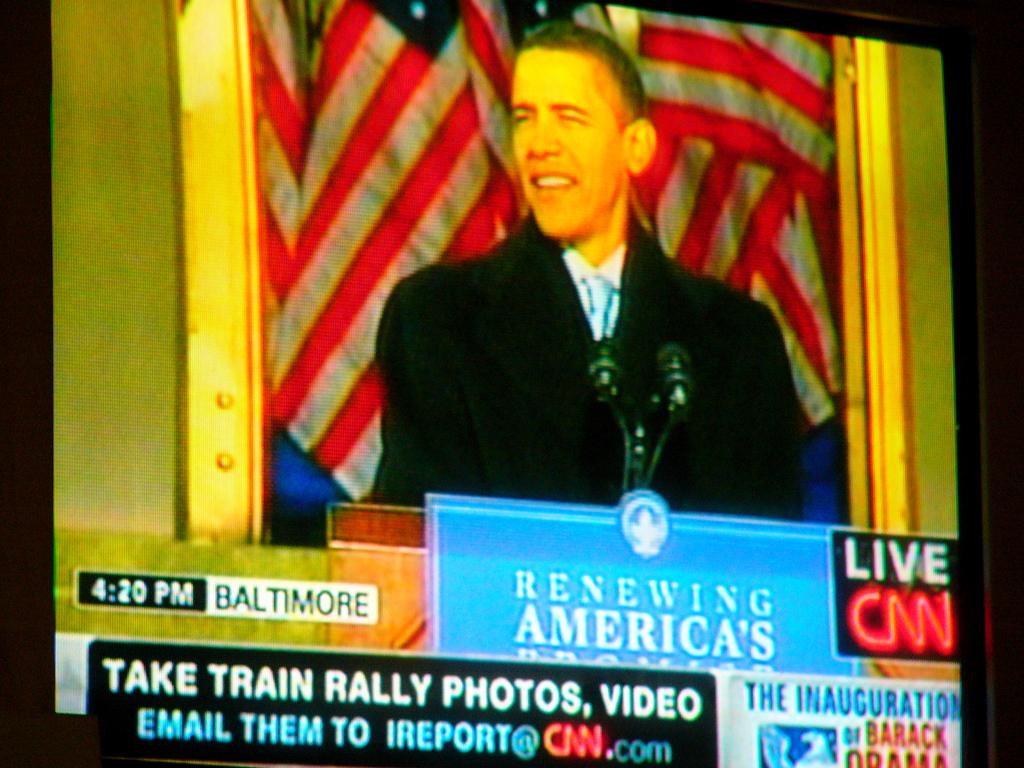What news channel is this?
Offer a terse response. Cnn. What time is shown?
Your answer should be very brief. 4:20. 